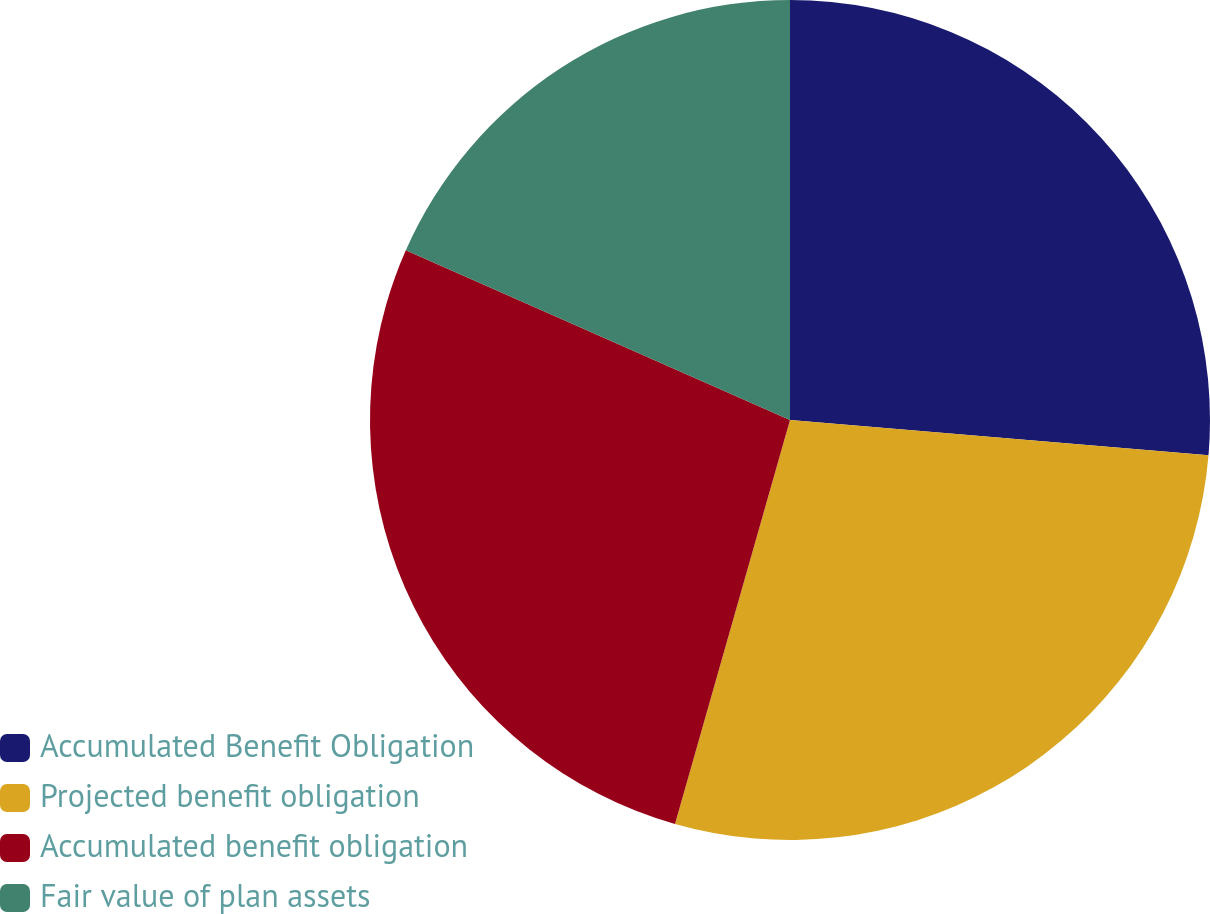Convert chart. <chart><loc_0><loc_0><loc_500><loc_500><pie_chart><fcel>Accumulated Benefit Obligation<fcel>Projected benefit obligation<fcel>Accumulated benefit obligation<fcel>Fair value of plan assets<nl><fcel>26.34%<fcel>28.08%<fcel>27.21%<fcel>18.38%<nl></chart> 